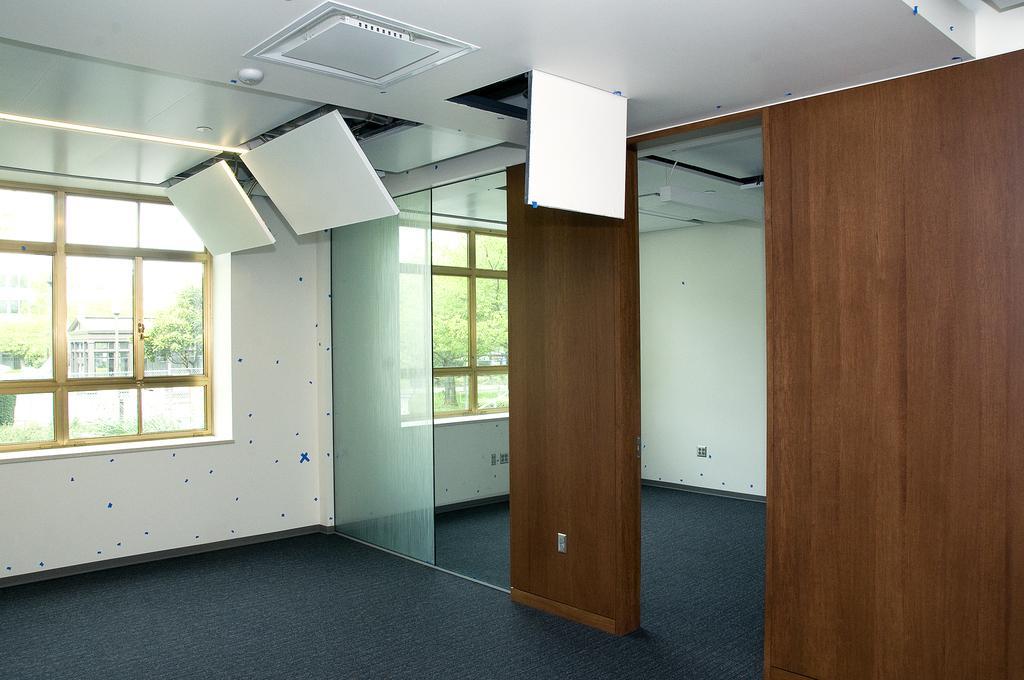How would you summarize this image in a sentence or two? In this image there are walls, glass, windows, carpet and objects. Through the windows I can see trees and a building.   